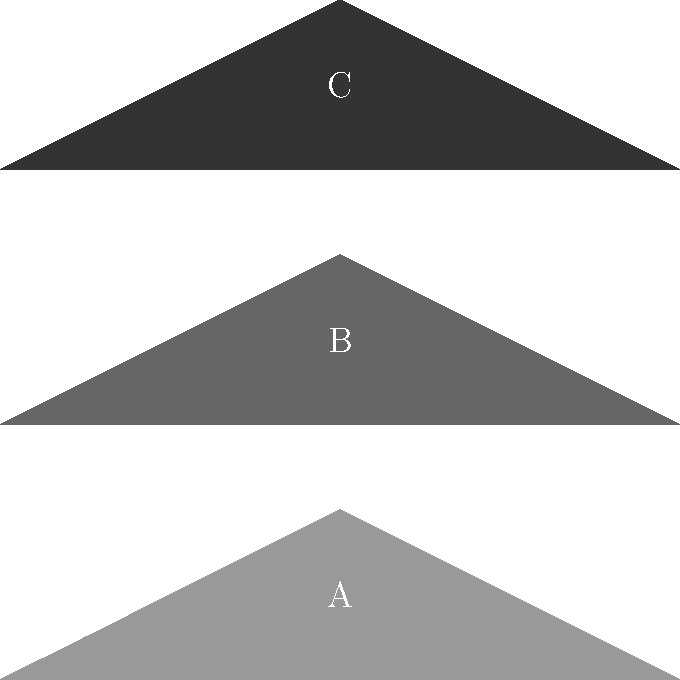In the image above, which silhouette most closely resembles the Predator from the original 1987 film, known for its iconic dreadlock-like appendages and mandibles? To answer this question, we need to analyze the three silhouettes and compare them to our knowledge of the original Predator design:

1. Silhouette A (bottom): This shape has a more rounded head with less pronounced features, which doesn't match the original Predator's distinctive look.

2. Silhouette B (middle): This silhouette shows a more elongated head shape with visible protrusions, resembling the dreadlock-like appendages of the original Predator. The overall shape is more consistent with the 1987 design.

3. Silhouette C (top): While this silhouette has some protruding features, the head shape appears too angular and doesn't quite capture the original Predator's look.

Based on these observations, silhouette B most closely resembles the Predator from the original 1987 film. It captures the distinctive head shape and the suggestion of the dreadlock-like appendages that made the original design so memorable and intimidating.
Answer: B 